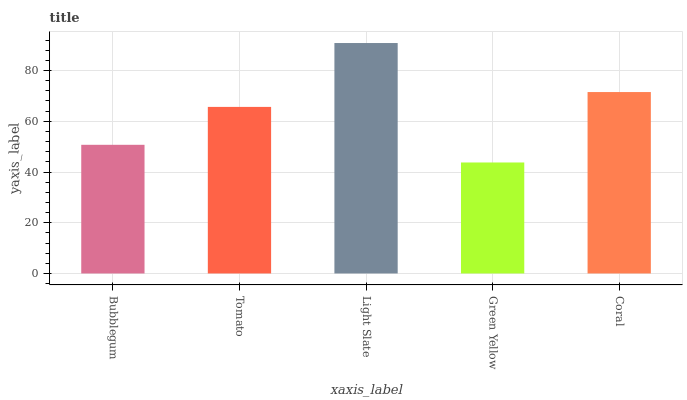Is Green Yellow the minimum?
Answer yes or no. Yes. Is Light Slate the maximum?
Answer yes or no. Yes. Is Tomato the minimum?
Answer yes or no. No. Is Tomato the maximum?
Answer yes or no. No. Is Tomato greater than Bubblegum?
Answer yes or no. Yes. Is Bubblegum less than Tomato?
Answer yes or no. Yes. Is Bubblegum greater than Tomato?
Answer yes or no. No. Is Tomato less than Bubblegum?
Answer yes or no. No. Is Tomato the high median?
Answer yes or no. Yes. Is Tomato the low median?
Answer yes or no. Yes. Is Green Yellow the high median?
Answer yes or no. No. Is Bubblegum the low median?
Answer yes or no. No. 